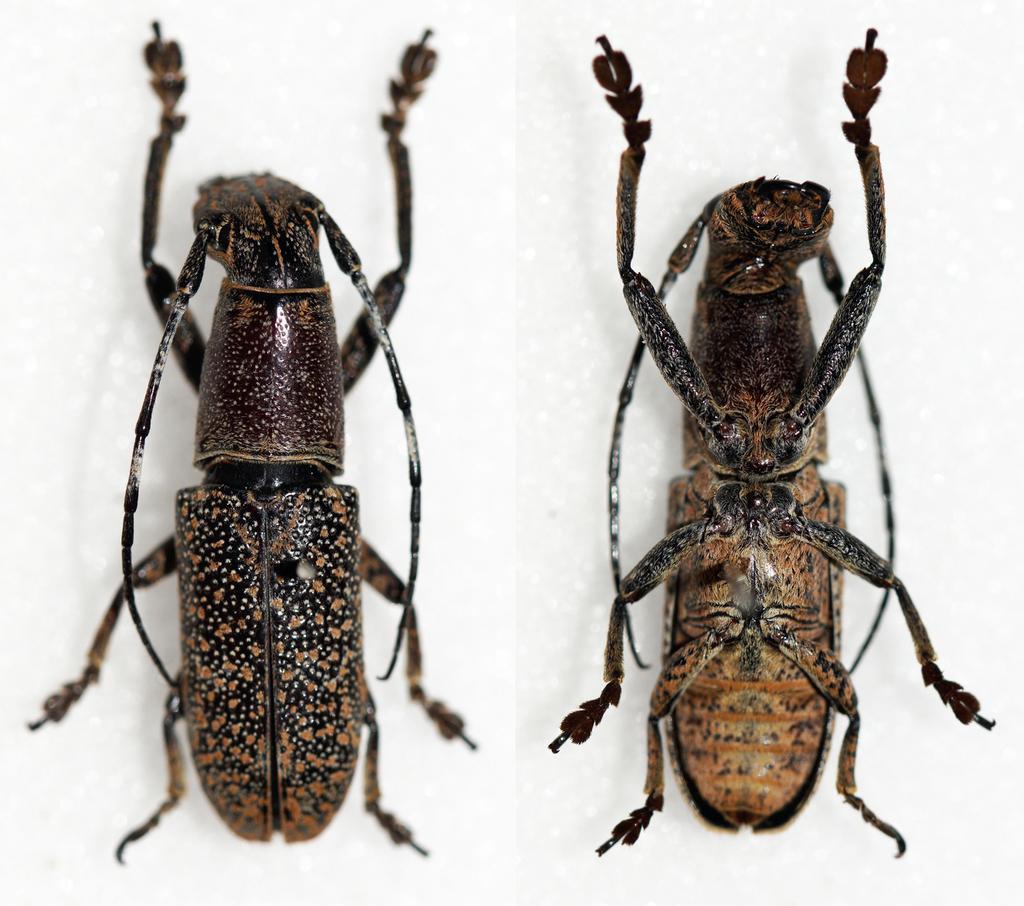Can you describe this image briefly? In this image we can see two insects with white color background. 